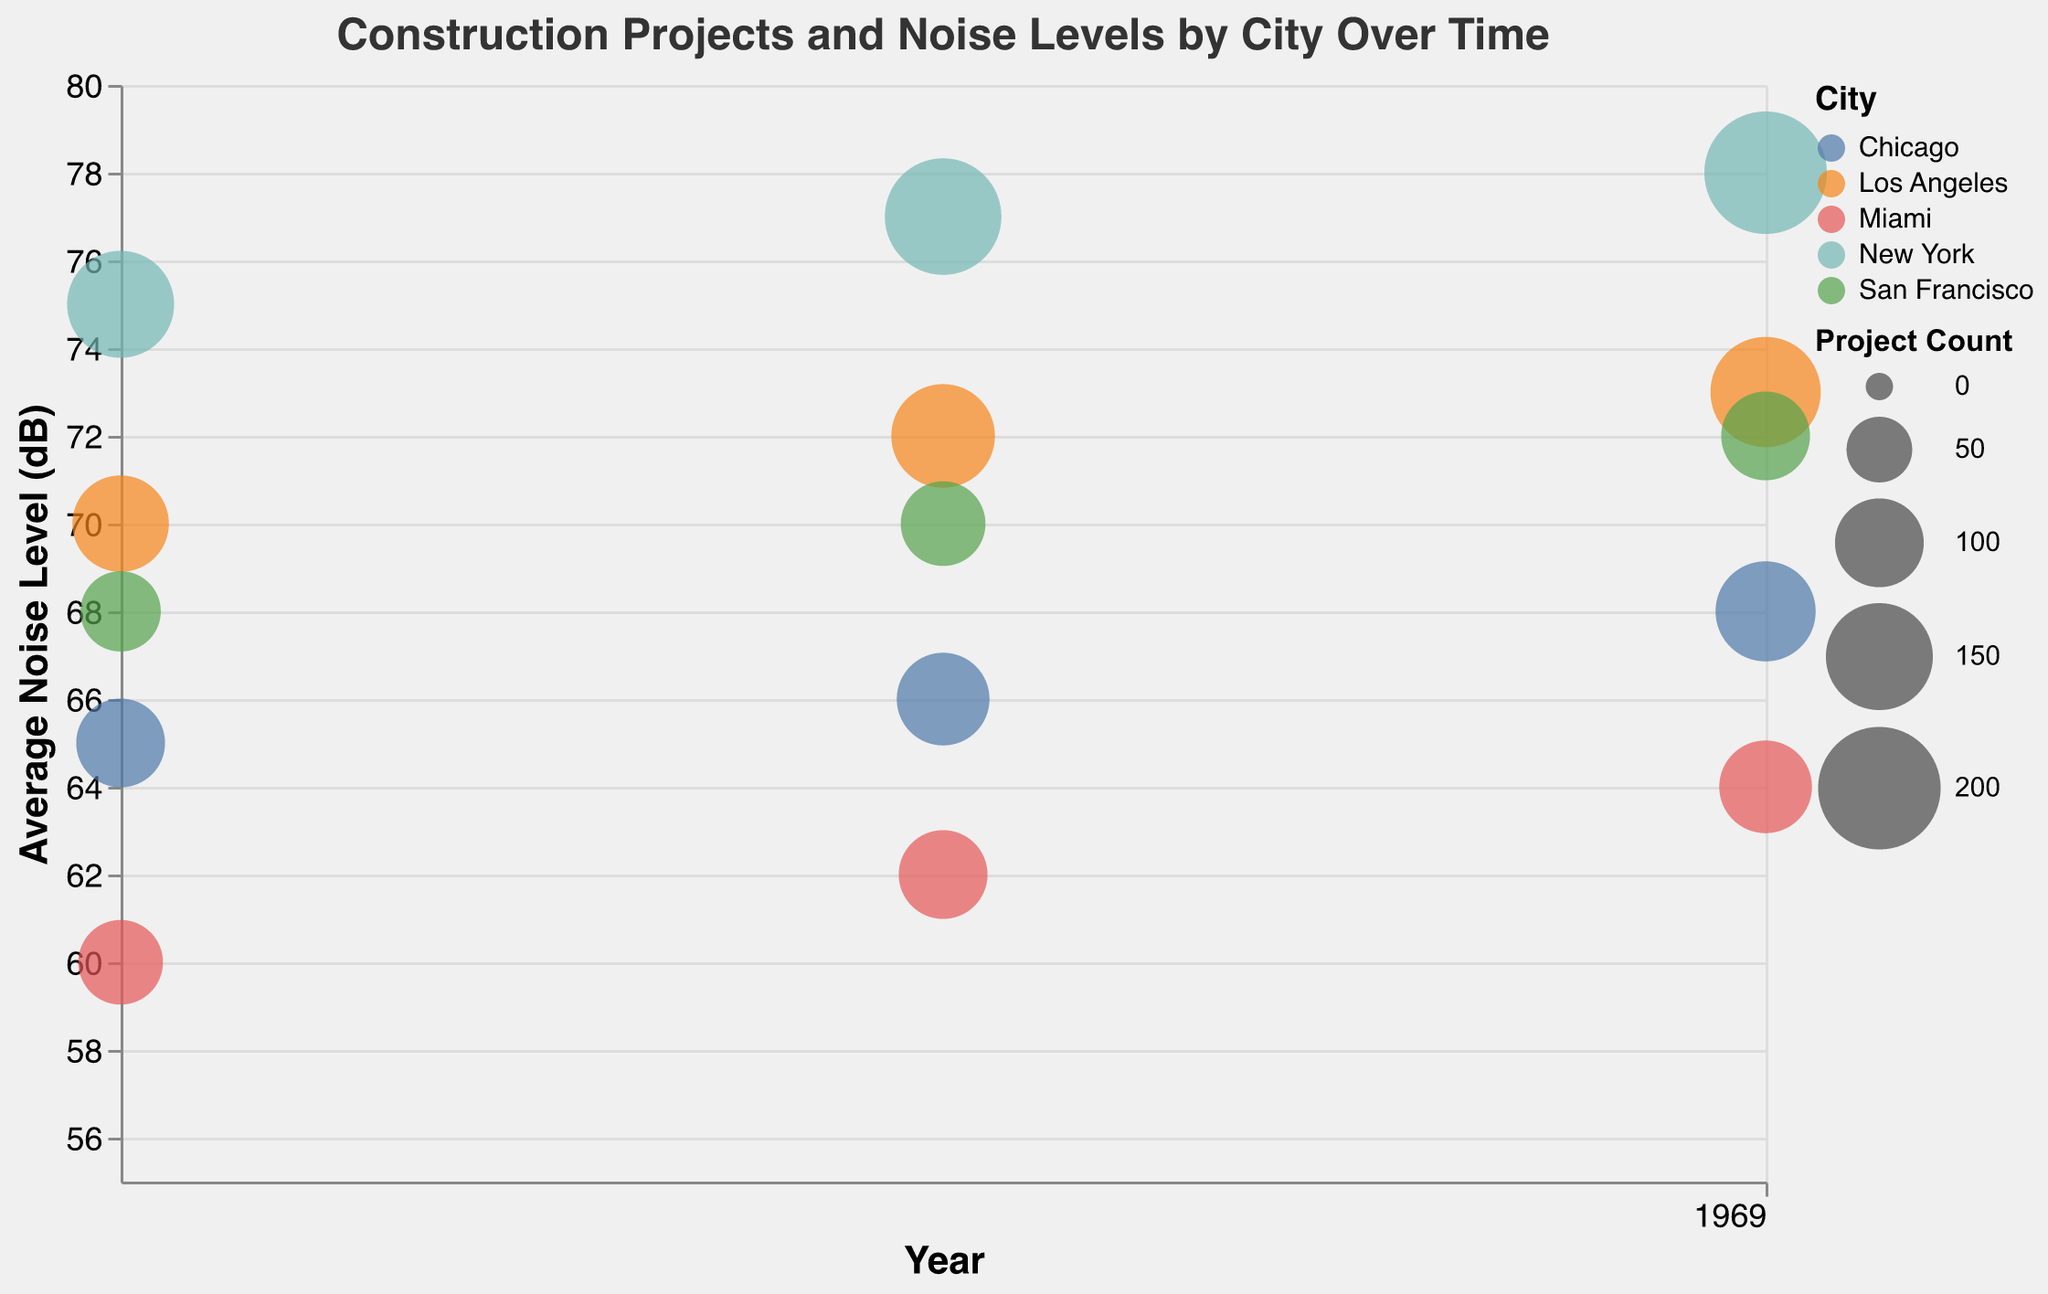What is the average noise level for Chicago in 2010? Look for the bubble corresponding to Chicago in the year 2010 and check its vertical position on the y-axis. The tooltip or information box can help you quickly find this specific data point.
Answer: 65 Which city had the highest average noise level in 2020? Inspect the bubbles corresponding to each city in the year 2020 and identify which one is positioned the highest on the y-axis, indicating the highest average noise level.
Answer: New York How did the nostalgia score for New York change from 2010 to 2020? Look at the nostalgia score provided in the tooltips for New York in 2010 and 2020, and observe the change. The nostalgia score increased from 8 in 2010 to 10 in 2020.
Answer: Increased by 2 Which city had the largest number of construction projects in 2015? Observe the size of the bubbles for each city for the year 2015. The largest bubble indicates the city with the most construction projects.
Answer: New York Compare the average noise levels of Los Angeles and Miami in 2015. Which city had a higher average noise level? Find the bubbles for Los Angeles and Miami in 2015 and compare their vertical positions on the y-axis. Los Angeles had a higher average noise level.
Answer: Los Angeles What is the total project count for San Francisco across all years? Sum the project counts for San Francisco for all recorded years (2010, 2015, and 2020). 80 + 90 + 100 = 270
Answer: 270 Which city shows the greatest increase in average noise level over the decade from 2010 to 2020? Calculate the difference in average noise levels between 2010 and 2020 for each city, then identify the city with the largest difference. New York increased from 75 dB (2010) to 78 dB (2020), Los Angeles from 70 dB to 73 dB, Chicago from 65 dB to 68 dB, Miami from 60 dB to 64 dB, and San Francisco from 68 dB to 72 dB. New York shows the highest increase of 3 dB.
Answer: New York 